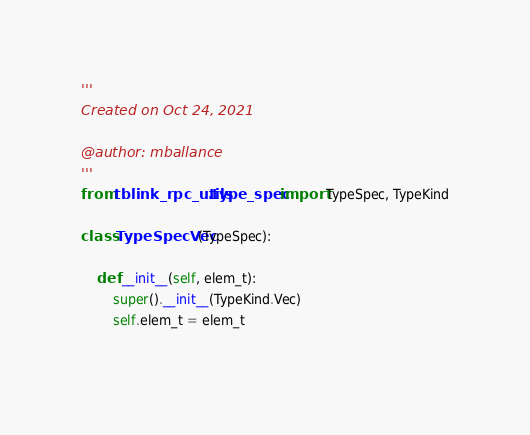<code> <loc_0><loc_0><loc_500><loc_500><_Python_>'''
Created on Oct 24, 2021

@author: mballance
'''
from tblink_rpc_utils.type_spec import TypeSpec, TypeKind

class TypeSpecVec(TypeSpec):
    
    def __init__(self, elem_t):
        super().__init__(TypeKind.Vec)
        self.elem_t = elem_t
        </code> 